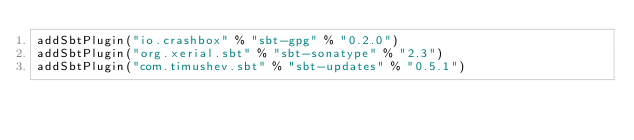<code> <loc_0><loc_0><loc_500><loc_500><_Scala_>addSbtPlugin("io.crashbox" % "sbt-gpg" % "0.2.0")
addSbtPlugin("org.xerial.sbt" % "sbt-sonatype" % "2.3")
addSbtPlugin("com.timushev.sbt" % "sbt-updates" % "0.5.1")</code> 